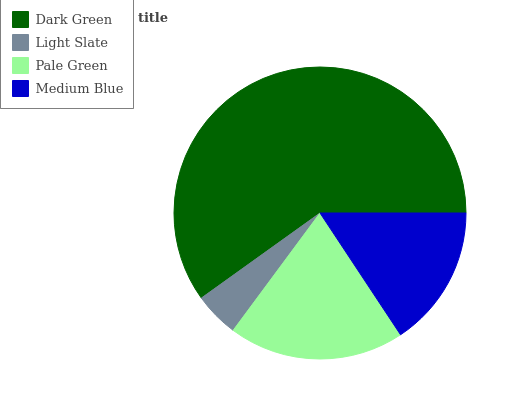Is Light Slate the minimum?
Answer yes or no. Yes. Is Dark Green the maximum?
Answer yes or no. Yes. Is Pale Green the minimum?
Answer yes or no. No. Is Pale Green the maximum?
Answer yes or no. No. Is Pale Green greater than Light Slate?
Answer yes or no. Yes. Is Light Slate less than Pale Green?
Answer yes or no. Yes. Is Light Slate greater than Pale Green?
Answer yes or no. No. Is Pale Green less than Light Slate?
Answer yes or no. No. Is Pale Green the high median?
Answer yes or no. Yes. Is Medium Blue the low median?
Answer yes or no. Yes. Is Medium Blue the high median?
Answer yes or no. No. Is Dark Green the low median?
Answer yes or no. No. 